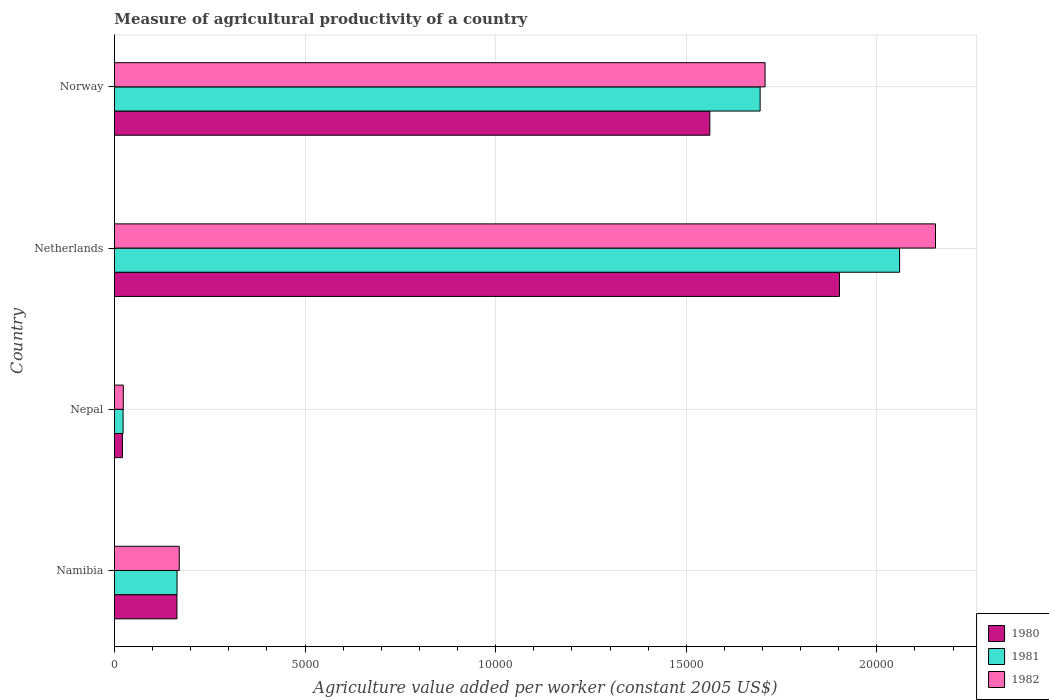Are the number of bars per tick equal to the number of legend labels?
Your answer should be compact. Yes. Are the number of bars on each tick of the Y-axis equal?
Provide a succinct answer. Yes. How many bars are there on the 1st tick from the bottom?
Offer a very short reply. 3. In how many cases, is the number of bars for a given country not equal to the number of legend labels?
Offer a very short reply. 0. What is the measure of agricultural productivity in 1981 in Norway?
Offer a terse response. 1.69e+04. Across all countries, what is the maximum measure of agricultural productivity in 1981?
Provide a short and direct response. 2.06e+04. Across all countries, what is the minimum measure of agricultural productivity in 1982?
Provide a succinct answer. 232.83. In which country was the measure of agricultural productivity in 1981 maximum?
Provide a short and direct response. Netherlands. In which country was the measure of agricultural productivity in 1981 minimum?
Your response must be concise. Nepal. What is the total measure of agricultural productivity in 1980 in the graph?
Your answer should be compact. 3.65e+04. What is the difference between the measure of agricultural productivity in 1982 in Netherlands and that in Norway?
Offer a terse response. 4471.16. What is the difference between the measure of agricultural productivity in 1982 in Namibia and the measure of agricultural productivity in 1980 in Norway?
Ensure brevity in your answer.  -1.39e+04. What is the average measure of agricultural productivity in 1980 per country?
Your answer should be very brief. 9121.81. What is the difference between the measure of agricultural productivity in 1980 and measure of agricultural productivity in 1981 in Namibia?
Give a very brief answer. -2.86. What is the ratio of the measure of agricultural productivity in 1981 in Namibia to that in Nepal?
Provide a succinct answer. 7.23. Is the measure of agricultural productivity in 1981 in Namibia less than that in Norway?
Your answer should be compact. Yes. What is the difference between the highest and the second highest measure of agricultural productivity in 1980?
Your response must be concise. 3401.71. What is the difference between the highest and the lowest measure of agricultural productivity in 1982?
Make the answer very short. 2.13e+04. What does the 1st bar from the bottom in Namibia represents?
Provide a succinct answer. 1980. How many bars are there?
Make the answer very short. 12. How many countries are there in the graph?
Ensure brevity in your answer.  4. What is the difference between two consecutive major ticks on the X-axis?
Offer a very short reply. 5000. Are the values on the major ticks of X-axis written in scientific E-notation?
Give a very brief answer. No. Does the graph contain any zero values?
Give a very brief answer. No. Does the graph contain grids?
Offer a very short reply. Yes. Where does the legend appear in the graph?
Make the answer very short. Bottom right. What is the title of the graph?
Ensure brevity in your answer.  Measure of agricultural productivity of a country. Does "1972" appear as one of the legend labels in the graph?
Keep it short and to the point. No. What is the label or title of the X-axis?
Provide a succinct answer. Agriculture value added per worker (constant 2005 US$). What is the label or title of the Y-axis?
Your answer should be very brief. Country. What is the Agriculture value added per worker (constant 2005 US$) in 1980 in Namibia?
Offer a terse response. 1639.69. What is the Agriculture value added per worker (constant 2005 US$) of 1981 in Namibia?
Make the answer very short. 1642.55. What is the Agriculture value added per worker (constant 2005 US$) of 1982 in Namibia?
Your response must be concise. 1699.99. What is the Agriculture value added per worker (constant 2005 US$) in 1980 in Nepal?
Provide a short and direct response. 210.09. What is the Agriculture value added per worker (constant 2005 US$) of 1981 in Nepal?
Make the answer very short. 227.07. What is the Agriculture value added per worker (constant 2005 US$) of 1982 in Nepal?
Ensure brevity in your answer.  232.83. What is the Agriculture value added per worker (constant 2005 US$) of 1980 in Netherlands?
Ensure brevity in your answer.  1.90e+04. What is the Agriculture value added per worker (constant 2005 US$) of 1981 in Netherlands?
Provide a succinct answer. 2.06e+04. What is the Agriculture value added per worker (constant 2005 US$) in 1982 in Netherlands?
Ensure brevity in your answer.  2.15e+04. What is the Agriculture value added per worker (constant 2005 US$) of 1980 in Norway?
Provide a succinct answer. 1.56e+04. What is the Agriculture value added per worker (constant 2005 US$) of 1981 in Norway?
Provide a short and direct response. 1.69e+04. What is the Agriculture value added per worker (constant 2005 US$) of 1982 in Norway?
Make the answer very short. 1.71e+04. Across all countries, what is the maximum Agriculture value added per worker (constant 2005 US$) of 1980?
Give a very brief answer. 1.90e+04. Across all countries, what is the maximum Agriculture value added per worker (constant 2005 US$) of 1981?
Offer a terse response. 2.06e+04. Across all countries, what is the maximum Agriculture value added per worker (constant 2005 US$) in 1982?
Your response must be concise. 2.15e+04. Across all countries, what is the minimum Agriculture value added per worker (constant 2005 US$) of 1980?
Keep it short and to the point. 210.09. Across all countries, what is the minimum Agriculture value added per worker (constant 2005 US$) in 1981?
Provide a succinct answer. 227.07. Across all countries, what is the minimum Agriculture value added per worker (constant 2005 US$) of 1982?
Give a very brief answer. 232.83. What is the total Agriculture value added per worker (constant 2005 US$) of 1980 in the graph?
Offer a terse response. 3.65e+04. What is the total Agriculture value added per worker (constant 2005 US$) of 1981 in the graph?
Give a very brief answer. 3.94e+04. What is the total Agriculture value added per worker (constant 2005 US$) of 1982 in the graph?
Your response must be concise. 4.05e+04. What is the difference between the Agriculture value added per worker (constant 2005 US$) of 1980 in Namibia and that in Nepal?
Keep it short and to the point. 1429.6. What is the difference between the Agriculture value added per worker (constant 2005 US$) in 1981 in Namibia and that in Nepal?
Make the answer very short. 1415.48. What is the difference between the Agriculture value added per worker (constant 2005 US$) of 1982 in Namibia and that in Nepal?
Your answer should be very brief. 1467.16. What is the difference between the Agriculture value added per worker (constant 2005 US$) in 1980 in Namibia and that in Netherlands?
Keep it short and to the point. -1.74e+04. What is the difference between the Agriculture value added per worker (constant 2005 US$) in 1981 in Namibia and that in Netherlands?
Provide a short and direct response. -1.90e+04. What is the difference between the Agriculture value added per worker (constant 2005 US$) in 1982 in Namibia and that in Netherlands?
Your answer should be compact. -1.98e+04. What is the difference between the Agriculture value added per worker (constant 2005 US$) in 1980 in Namibia and that in Norway?
Make the answer very short. -1.40e+04. What is the difference between the Agriculture value added per worker (constant 2005 US$) in 1981 in Namibia and that in Norway?
Provide a succinct answer. -1.53e+04. What is the difference between the Agriculture value added per worker (constant 2005 US$) of 1982 in Namibia and that in Norway?
Offer a terse response. -1.54e+04. What is the difference between the Agriculture value added per worker (constant 2005 US$) of 1980 in Nepal and that in Netherlands?
Provide a short and direct response. -1.88e+04. What is the difference between the Agriculture value added per worker (constant 2005 US$) in 1981 in Nepal and that in Netherlands?
Offer a very short reply. -2.04e+04. What is the difference between the Agriculture value added per worker (constant 2005 US$) in 1982 in Nepal and that in Netherlands?
Offer a terse response. -2.13e+04. What is the difference between the Agriculture value added per worker (constant 2005 US$) in 1980 in Nepal and that in Norway?
Offer a terse response. -1.54e+04. What is the difference between the Agriculture value added per worker (constant 2005 US$) in 1981 in Nepal and that in Norway?
Offer a terse response. -1.67e+04. What is the difference between the Agriculture value added per worker (constant 2005 US$) of 1982 in Nepal and that in Norway?
Make the answer very short. -1.68e+04. What is the difference between the Agriculture value added per worker (constant 2005 US$) in 1980 in Netherlands and that in Norway?
Keep it short and to the point. 3401.71. What is the difference between the Agriculture value added per worker (constant 2005 US$) in 1981 in Netherlands and that in Norway?
Give a very brief answer. 3658.56. What is the difference between the Agriculture value added per worker (constant 2005 US$) of 1982 in Netherlands and that in Norway?
Offer a terse response. 4471.16. What is the difference between the Agriculture value added per worker (constant 2005 US$) in 1980 in Namibia and the Agriculture value added per worker (constant 2005 US$) in 1981 in Nepal?
Offer a very short reply. 1412.62. What is the difference between the Agriculture value added per worker (constant 2005 US$) of 1980 in Namibia and the Agriculture value added per worker (constant 2005 US$) of 1982 in Nepal?
Keep it short and to the point. 1406.86. What is the difference between the Agriculture value added per worker (constant 2005 US$) in 1981 in Namibia and the Agriculture value added per worker (constant 2005 US$) in 1982 in Nepal?
Your response must be concise. 1409.72. What is the difference between the Agriculture value added per worker (constant 2005 US$) of 1980 in Namibia and the Agriculture value added per worker (constant 2005 US$) of 1981 in Netherlands?
Ensure brevity in your answer.  -1.90e+04. What is the difference between the Agriculture value added per worker (constant 2005 US$) in 1980 in Namibia and the Agriculture value added per worker (constant 2005 US$) in 1982 in Netherlands?
Your answer should be very brief. -1.99e+04. What is the difference between the Agriculture value added per worker (constant 2005 US$) in 1981 in Namibia and the Agriculture value added per worker (constant 2005 US$) in 1982 in Netherlands?
Offer a terse response. -1.99e+04. What is the difference between the Agriculture value added per worker (constant 2005 US$) of 1980 in Namibia and the Agriculture value added per worker (constant 2005 US$) of 1981 in Norway?
Provide a short and direct response. -1.53e+04. What is the difference between the Agriculture value added per worker (constant 2005 US$) of 1980 in Namibia and the Agriculture value added per worker (constant 2005 US$) of 1982 in Norway?
Keep it short and to the point. -1.54e+04. What is the difference between the Agriculture value added per worker (constant 2005 US$) in 1981 in Namibia and the Agriculture value added per worker (constant 2005 US$) in 1982 in Norway?
Your response must be concise. -1.54e+04. What is the difference between the Agriculture value added per worker (constant 2005 US$) of 1980 in Nepal and the Agriculture value added per worker (constant 2005 US$) of 1981 in Netherlands?
Offer a terse response. -2.04e+04. What is the difference between the Agriculture value added per worker (constant 2005 US$) of 1980 in Nepal and the Agriculture value added per worker (constant 2005 US$) of 1982 in Netherlands?
Offer a terse response. -2.13e+04. What is the difference between the Agriculture value added per worker (constant 2005 US$) of 1981 in Nepal and the Agriculture value added per worker (constant 2005 US$) of 1982 in Netherlands?
Offer a very short reply. -2.13e+04. What is the difference between the Agriculture value added per worker (constant 2005 US$) in 1980 in Nepal and the Agriculture value added per worker (constant 2005 US$) in 1981 in Norway?
Offer a very short reply. -1.67e+04. What is the difference between the Agriculture value added per worker (constant 2005 US$) of 1980 in Nepal and the Agriculture value added per worker (constant 2005 US$) of 1982 in Norway?
Your answer should be very brief. -1.69e+04. What is the difference between the Agriculture value added per worker (constant 2005 US$) of 1981 in Nepal and the Agriculture value added per worker (constant 2005 US$) of 1982 in Norway?
Offer a terse response. -1.68e+04. What is the difference between the Agriculture value added per worker (constant 2005 US$) in 1980 in Netherlands and the Agriculture value added per worker (constant 2005 US$) in 1981 in Norway?
Make the answer very short. 2081.76. What is the difference between the Agriculture value added per worker (constant 2005 US$) in 1980 in Netherlands and the Agriculture value added per worker (constant 2005 US$) in 1982 in Norway?
Your answer should be very brief. 1952.22. What is the difference between the Agriculture value added per worker (constant 2005 US$) in 1981 in Netherlands and the Agriculture value added per worker (constant 2005 US$) in 1982 in Norway?
Offer a terse response. 3529.02. What is the average Agriculture value added per worker (constant 2005 US$) of 1980 per country?
Your answer should be very brief. 9121.81. What is the average Agriculture value added per worker (constant 2005 US$) of 1981 per country?
Make the answer very short. 9850.96. What is the average Agriculture value added per worker (constant 2005 US$) of 1982 per country?
Keep it short and to the point. 1.01e+04. What is the difference between the Agriculture value added per worker (constant 2005 US$) in 1980 and Agriculture value added per worker (constant 2005 US$) in 1981 in Namibia?
Give a very brief answer. -2.86. What is the difference between the Agriculture value added per worker (constant 2005 US$) in 1980 and Agriculture value added per worker (constant 2005 US$) in 1982 in Namibia?
Your answer should be compact. -60.3. What is the difference between the Agriculture value added per worker (constant 2005 US$) of 1981 and Agriculture value added per worker (constant 2005 US$) of 1982 in Namibia?
Give a very brief answer. -57.44. What is the difference between the Agriculture value added per worker (constant 2005 US$) of 1980 and Agriculture value added per worker (constant 2005 US$) of 1981 in Nepal?
Ensure brevity in your answer.  -16.98. What is the difference between the Agriculture value added per worker (constant 2005 US$) in 1980 and Agriculture value added per worker (constant 2005 US$) in 1982 in Nepal?
Your answer should be compact. -22.74. What is the difference between the Agriculture value added per worker (constant 2005 US$) of 1981 and Agriculture value added per worker (constant 2005 US$) of 1982 in Nepal?
Give a very brief answer. -5.76. What is the difference between the Agriculture value added per worker (constant 2005 US$) of 1980 and Agriculture value added per worker (constant 2005 US$) of 1981 in Netherlands?
Give a very brief answer. -1576.8. What is the difference between the Agriculture value added per worker (constant 2005 US$) of 1980 and Agriculture value added per worker (constant 2005 US$) of 1982 in Netherlands?
Offer a terse response. -2518.94. What is the difference between the Agriculture value added per worker (constant 2005 US$) of 1981 and Agriculture value added per worker (constant 2005 US$) of 1982 in Netherlands?
Offer a terse response. -942.14. What is the difference between the Agriculture value added per worker (constant 2005 US$) in 1980 and Agriculture value added per worker (constant 2005 US$) in 1981 in Norway?
Provide a short and direct response. -1319.95. What is the difference between the Agriculture value added per worker (constant 2005 US$) of 1980 and Agriculture value added per worker (constant 2005 US$) of 1982 in Norway?
Your answer should be very brief. -1449.49. What is the difference between the Agriculture value added per worker (constant 2005 US$) in 1981 and Agriculture value added per worker (constant 2005 US$) in 1982 in Norway?
Provide a succinct answer. -129.54. What is the ratio of the Agriculture value added per worker (constant 2005 US$) of 1980 in Namibia to that in Nepal?
Keep it short and to the point. 7.8. What is the ratio of the Agriculture value added per worker (constant 2005 US$) in 1981 in Namibia to that in Nepal?
Your response must be concise. 7.23. What is the ratio of the Agriculture value added per worker (constant 2005 US$) of 1982 in Namibia to that in Nepal?
Offer a very short reply. 7.3. What is the ratio of the Agriculture value added per worker (constant 2005 US$) of 1980 in Namibia to that in Netherlands?
Offer a very short reply. 0.09. What is the ratio of the Agriculture value added per worker (constant 2005 US$) of 1981 in Namibia to that in Netherlands?
Your response must be concise. 0.08. What is the ratio of the Agriculture value added per worker (constant 2005 US$) in 1982 in Namibia to that in Netherlands?
Ensure brevity in your answer.  0.08. What is the ratio of the Agriculture value added per worker (constant 2005 US$) in 1980 in Namibia to that in Norway?
Make the answer very short. 0.1. What is the ratio of the Agriculture value added per worker (constant 2005 US$) in 1981 in Namibia to that in Norway?
Your answer should be compact. 0.1. What is the ratio of the Agriculture value added per worker (constant 2005 US$) of 1982 in Namibia to that in Norway?
Offer a very short reply. 0.1. What is the ratio of the Agriculture value added per worker (constant 2005 US$) of 1980 in Nepal to that in Netherlands?
Provide a succinct answer. 0.01. What is the ratio of the Agriculture value added per worker (constant 2005 US$) in 1981 in Nepal to that in Netherlands?
Ensure brevity in your answer.  0.01. What is the ratio of the Agriculture value added per worker (constant 2005 US$) in 1982 in Nepal to that in Netherlands?
Provide a short and direct response. 0.01. What is the ratio of the Agriculture value added per worker (constant 2005 US$) of 1980 in Nepal to that in Norway?
Offer a terse response. 0.01. What is the ratio of the Agriculture value added per worker (constant 2005 US$) of 1981 in Nepal to that in Norway?
Keep it short and to the point. 0.01. What is the ratio of the Agriculture value added per worker (constant 2005 US$) of 1982 in Nepal to that in Norway?
Offer a very short reply. 0.01. What is the ratio of the Agriculture value added per worker (constant 2005 US$) in 1980 in Netherlands to that in Norway?
Offer a terse response. 1.22. What is the ratio of the Agriculture value added per worker (constant 2005 US$) of 1981 in Netherlands to that in Norway?
Ensure brevity in your answer.  1.22. What is the ratio of the Agriculture value added per worker (constant 2005 US$) of 1982 in Netherlands to that in Norway?
Provide a succinct answer. 1.26. What is the difference between the highest and the second highest Agriculture value added per worker (constant 2005 US$) of 1980?
Keep it short and to the point. 3401.71. What is the difference between the highest and the second highest Agriculture value added per worker (constant 2005 US$) of 1981?
Keep it short and to the point. 3658.56. What is the difference between the highest and the second highest Agriculture value added per worker (constant 2005 US$) in 1982?
Offer a very short reply. 4471.16. What is the difference between the highest and the lowest Agriculture value added per worker (constant 2005 US$) of 1980?
Your response must be concise. 1.88e+04. What is the difference between the highest and the lowest Agriculture value added per worker (constant 2005 US$) of 1981?
Provide a succinct answer. 2.04e+04. What is the difference between the highest and the lowest Agriculture value added per worker (constant 2005 US$) in 1982?
Offer a terse response. 2.13e+04. 